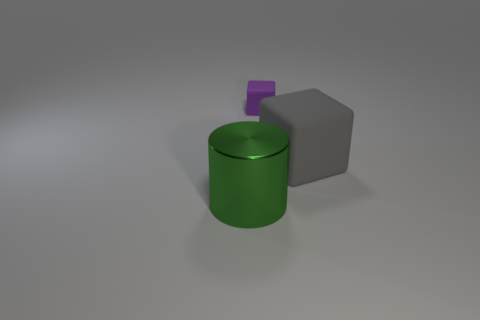What is the shape of the rubber object that is on the left side of the rubber thing that is right of the matte cube that is behind the gray thing? If we analyze the image carefully, we notice there are three distinct objects. Starting with the 'gray thing,' which in this context appears to be a matte gray cube, we then consider the 'rubber thing' to the right of it, which is actually a shiny green cylinder. Now, to find the object in question, we look to the left side of the green cylinder and identify a small purple cube. Therefore, the rubber object on the left side of the green cylinder is a cube, which coincides with the model's answer but the interpretation of 'rubber thing' might not be correct as we don't have enough context to determine the materials. 